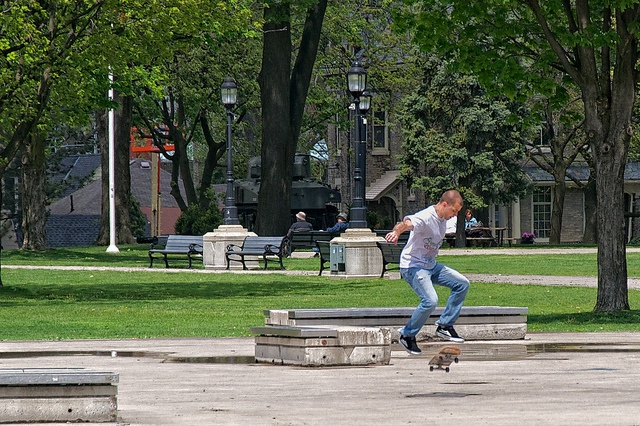Describe the objects in this image and their specific colors. I can see people in black, darkgray, gray, and lightgray tones, bench in black, darkgray, gray, and lightgray tones, bench in black, darkgray, gray, and lightgray tones, bench in black, darkgray, and gray tones, and bench in black, darkgray, and gray tones in this image. 